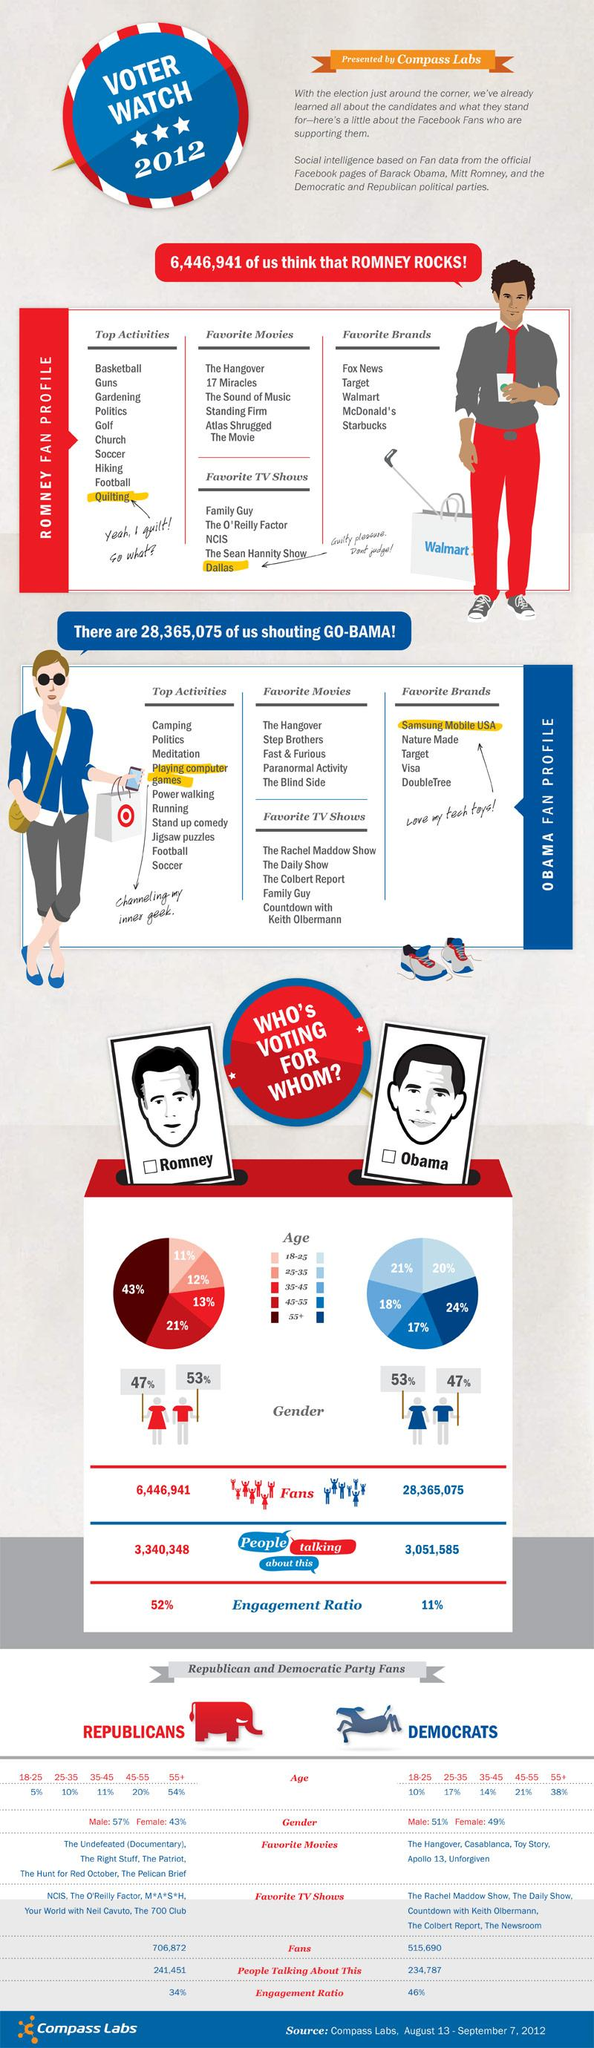Specify some key components in this picture. According to a recent survey, 21% of individuals who voted for Mitt Romney fall within the age group of 45-55. The engagement ratio of those favoring Obama is 11%. There are 3,340,348 people actively discussing their support for Mitt Romney. According to a recent survey, 53% of men are expected to vote for Romney in the upcoming election. According to a recent survey, 53% of women are voting for Obama in the upcoming election. 